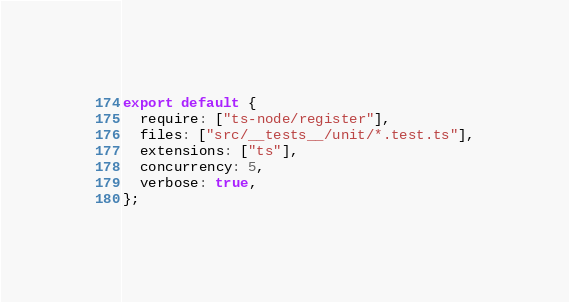<code> <loc_0><loc_0><loc_500><loc_500><_JavaScript_>export default {
  require: ["ts-node/register"],
  files: ["src/__tests__/unit/*.test.ts"],
  extensions: ["ts"],
  concurrency: 5,
  verbose: true,
};
</code> 